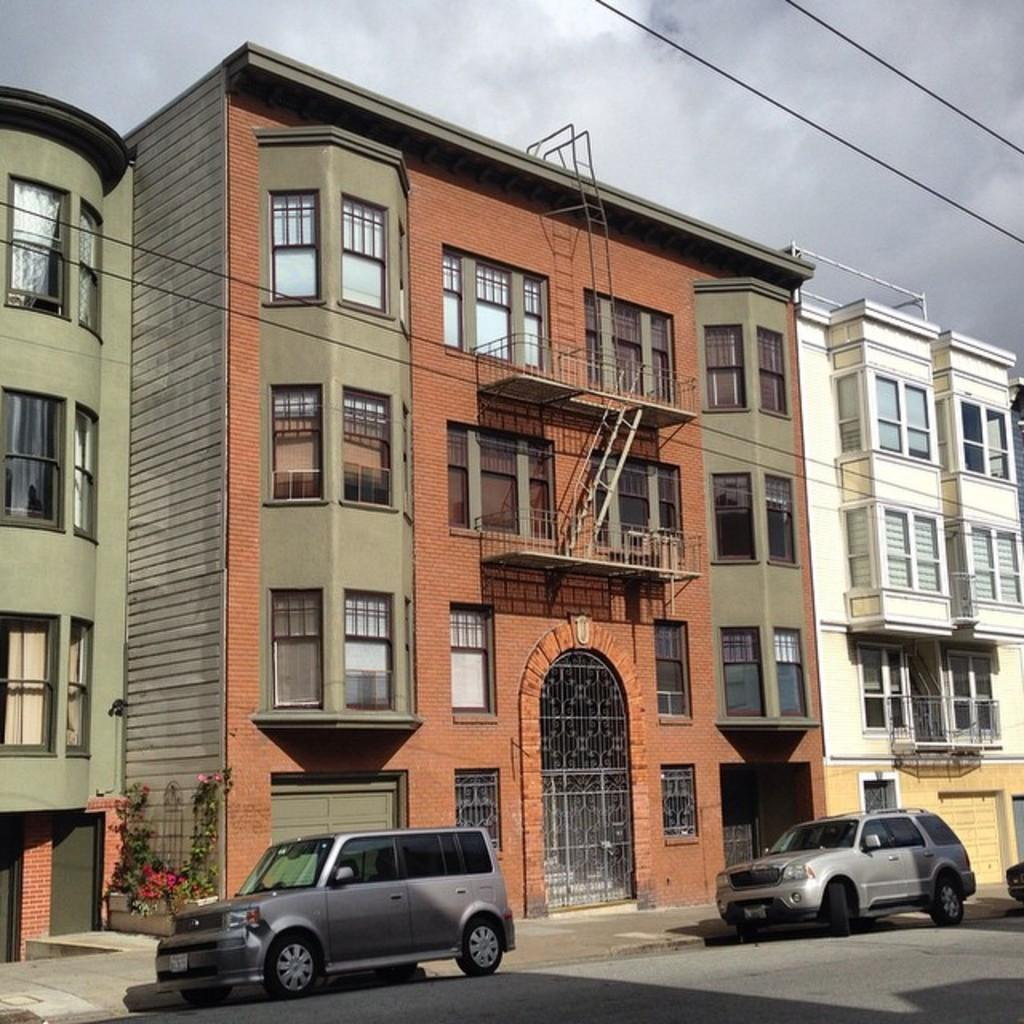What vehicles are present in the image? There are two cars in the front of the image. What type of structures can be seen in the background? There are buildings in the background of the image. What kind of vegetation is on the left side of the image? There are plants on the left side of the image. What is visible at the top of the image? The sky is visible at the top of the image. What type of seed is being planted in the image? There is no seed or planting activity depicted in the image. Can you tell me how many rifles are visible in the image? There are no rifles present in the image. 